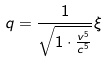Convert formula to latex. <formula><loc_0><loc_0><loc_500><loc_500>q = \frac { 1 } { \sqrt { 1 \cdot \frac { v ^ { 5 } } { c ^ { 5 } } } } \xi</formula> 